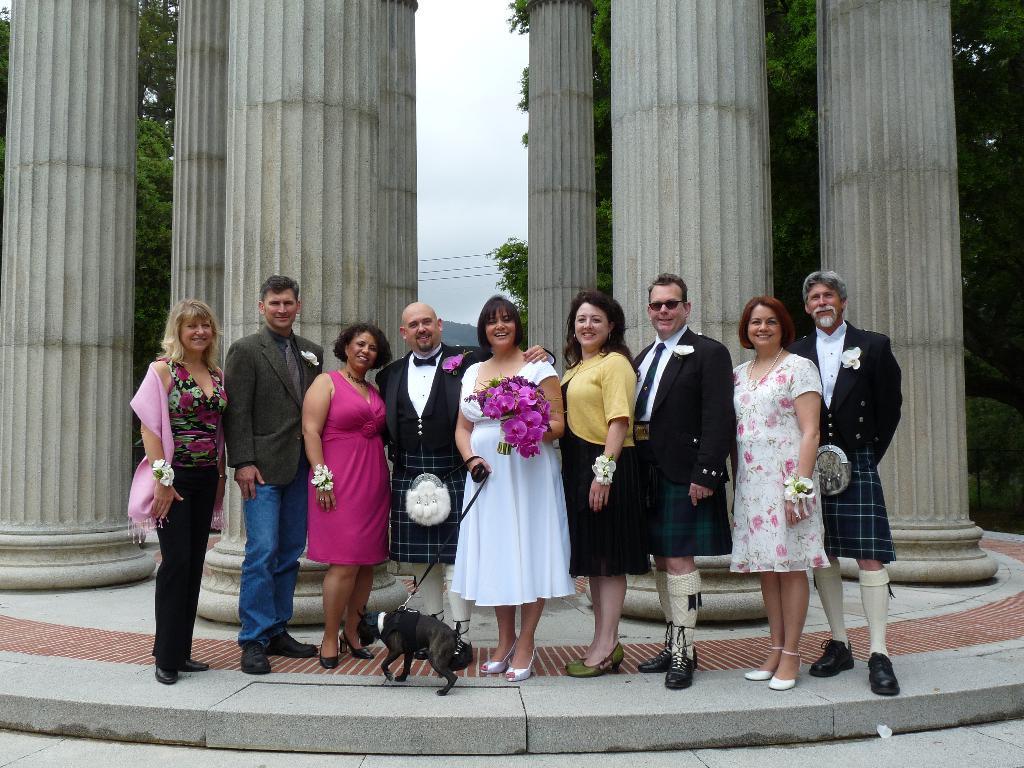Describe this image in one or two sentences. In the background we can see the sky, transmission wires, trees and pillars. In this picture we can see the people standing and all are smiling. We can see a woman wearing a white dress, she is holding flowers in her hand and with the other hand she is holding the belt of a puppy. At the bottom portion of the picture we can see the floor. 